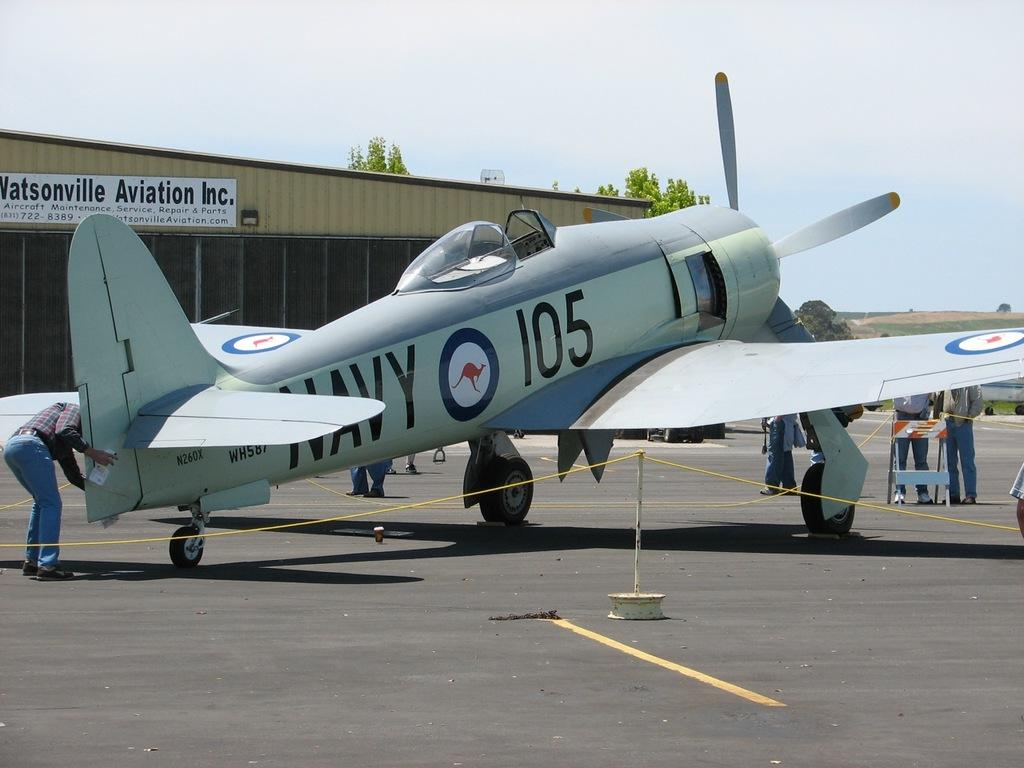<image>
Share a concise interpretation of the image provided. A small plane with the number 105 written towards the front. 